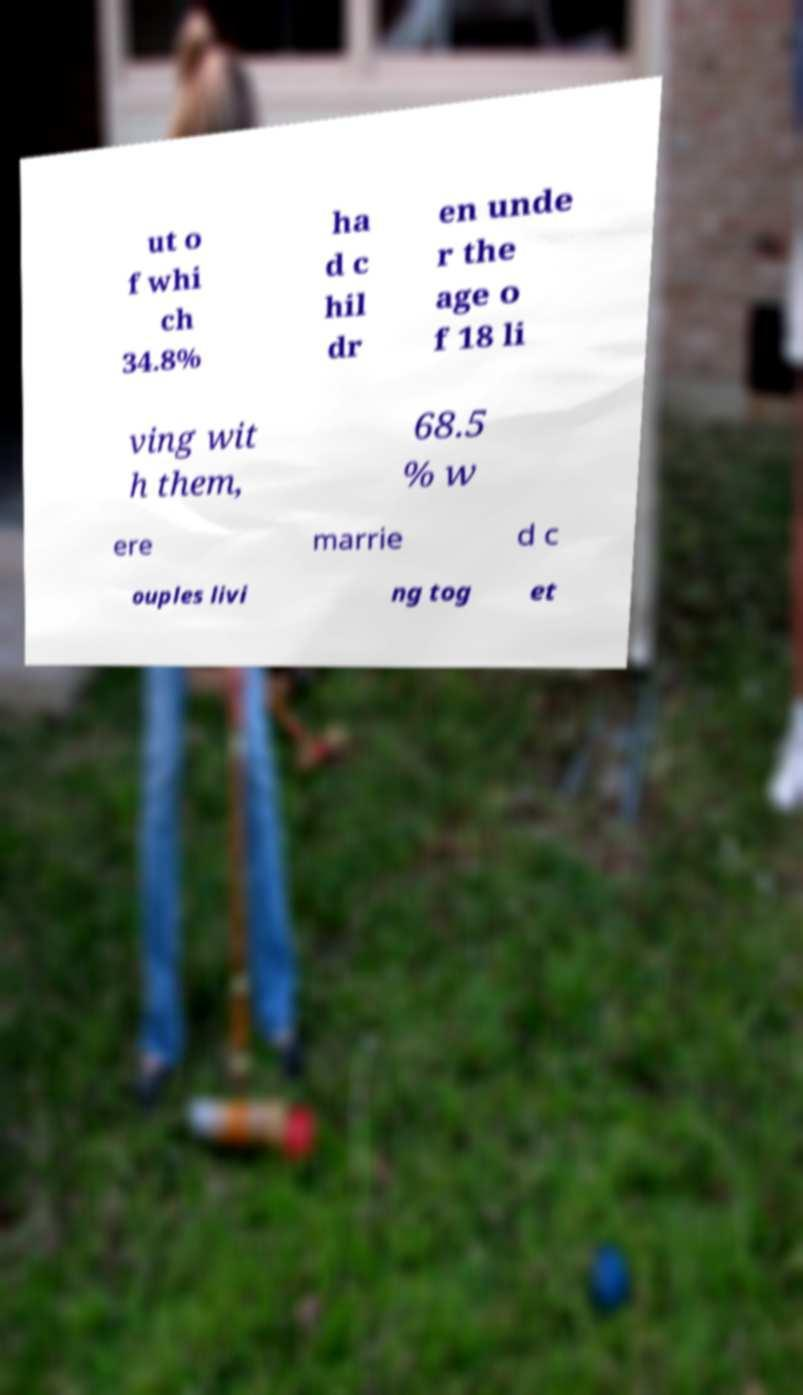For documentation purposes, I need the text within this image transcribed. Could you provide that? ut o f whi ch 34.8% ha d c hil dr en unde r the age o f 18 li ving wit h them, 68.5 % w ere marrie d c ouples livi ng tog et 